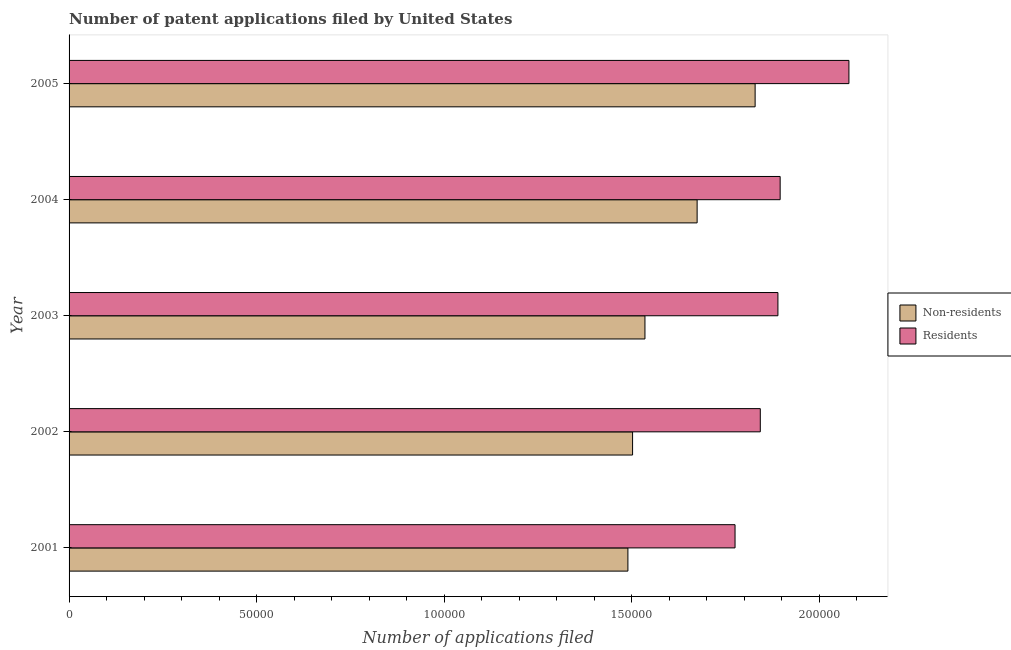Are the number of bars per tick equal to the number of legend labels?
Offer a terse response. Yes. How many bars are there on the 2nd tick from the top?
Make the answer very short. 2. How many bars are there on the 1st tick from the bottom?
Keep it short and to the point. 2. In how many cases, is the number of bars for a given year not equal to the number of legend labels?
Your response must be concise. 0. What is the number of patent applications by non residents in 2004?
Keep it short and to the point. 1.67e+05. Across all years, what is the maximum number of patent applications by residents?
Offer a very short reply. 2.08e+05. Across all years, what is the minimum number of patent applications by residents?
Keep it short and to the point. 1.78e+05. In which year was the number of patent applications by residents minimum?
Provide a short and direct response. 2001. What is the total number of patent applications by residents in the graph?
Make the answer very short. 9.48e+05. What is the difference between the number of patent applications by non residents in 2002 and that in 2005?
Your answer should be very brief. -3.27e+04. What is the difference between the number of patent applications by residents in 2004 and the number of patent applications by non residents in 2005?
Make the answer very short. 6670. What is the average number of patent applications by non residents per year?
Your answer should be compact. 1.61e+05. In the year 2001, what is the difference between the number of patent applications by residents and number of patent applications by non residents?
Give a very brief answer. 2.86e+04. What is the ratio of the number of patent applications by non residents in 2001 to that in 2005?
Keep it short and to the point. 0.81. Is the number of patent applications by non residents in 2001 less than that in 2002?
Offer a very short reply. Yes. What is the difference between the highest and the second highest number of patent applications by non residents?
Your answer should be very brief. 1.55e+04. What is the difference between the highest and the lowest number of patent applications by residents?
Keep it short and to the point. 3.04e+04. Is the sum of the number of patent applications by residents in 2001 and 2002 greater than the maximum number of patent applications by non residents across all years?
Ensure brevity in your answer.  Yes. What does the 2nd bar from the top in 2003 represents?
Make the answer very short. Non-residents. What does the 2nd bar from the bottom in 2005 represents?
Offer a terse response. Residents. How many bars are there?
Provide a short and direct response. 10. What is the difference between two consecutive major ticks on the X-axis?
Keep it short and to the point. 5.00e+04. Are the values on the major ticks of X-axis written in scientific E-notation?
Your answer should be compact. No. Where does the legend appear in the graph?
Provide a succinct answer. Center right. What is the title of the graph?
Provide a succinct answer. Number of patent applications filed by United States. Does "Borrowers" appear as one of the legend labels in the graph?
Provide a succinct answer. No. What is the label or title of the X-axis?
Make the answer very short. Number of applications filed. What is the Number of applications filed in Non-residents in 2001?
Keep it short and to the point. 1.49e+05. What is the Number of applications filed of Residents in 2001?
Give a very brief answer. 1.78e+05. What is the Number of applications filed of Non-residents in 2002?
Offer a terse response. 1.50e+05. What is the Number of applications filed in Residents in 2002?
Give a very brief answer. 1.84e+05. What is the Number of applications filed in Non-residents in 2003?
Offer a terse response. 1.54e+05. What is the Number of applications filed of Residents in 2003?
Your answer should be very brief. 1.89e+05. What is the Number of applications filed of Non-residents in 2004?
Offer a terse response. 1.67e+05. What is the Number of applications filed of Residents in 2004?
Ensure brevity in your answer.  1.90e+05. What is the Number of applications filed in Non-residents in 2005?
Your answer should be very brief. 1.83e+05. What is the Number of applications filed in Residents in 2005?
Make the answer very short. 2.08e+05. Across all years, what is the maximum Number of applications filed of Non-residents?
Offer a very short reply. 1.83e+05. Across all years, what is the maximum Number of applications filed in Residents?
Ensure brevity in your answer.  2.08e+05. Across all years, what is the minimum Number of applications filed in Non-residents?
Ensure brevity in your answer.  1.49e+05. Across all years, what is the minimum Number of applications filed of Residents?
Provide a succinct answer. 1.78e+05. What is the total Number of applications filed of Non-residents in the graph?
Provide a short and direct response. 8.03e+05. What is the total Number of applications filed in Residents in the graph?
Your response must be concise. 9.48e+05. What is the difference between the Number of applications filed of Non-residents in 2001 and that in 2002?
Provide a short and direct response. -1242. What is the difference between the Number of applications filed of Residents in 2001 and that in 2002?
Offer a terse response. -6732. What is the difference between the Number of applications filed of Non-residents in 2001 and that in 2003?
Keep it short and to the point. -4542. What is the difference between the Number of applications filed in Residents in 2001 and that in 2003?
Offer a very short reply. -1.14e+04. What is the difference between the Number of applications filed in Non-residents in 2001 and that in 2004?
Your answer should be very brief. -1.84e+04. What is the difference between the Number of applications filed in Residents in 2001 and that in 2004?
Your response must be concise. -1.20e+04. What is the difference between the Number of applications filed of Non-residents in 2001 and that in 2005?
Provide a short and direct response. -3.39e+04. What is the difference between the Number of applications filed of Residents in 2001 and that in 2005?
Give a very brief answer. -3.04e+04. What is the difference between the Number of applications filed in Non-residents in 2002 and that in 2003?
Offer a terse response. -3300. What is the difference between the Number of applications filed of Residents in 2002 and that in 2003?
Your response must be concise. -4696. What is the difference between the Number of applications filed of Non-residents in 2002 and that in 2004?
Offer a terse response. -1.72e+04. What is the difference between the Number of applications filed of Residents in 2002 and that in 2004?
Your answer should be very brief. -5291. What is the difference between the Number of applications filed of Non-residents in 2002 and that in 2005?
Offer a very short reply. -3.27e+04. What is the difference between the Number of applications filed of Residents in 2002 and that in 2005?
Your response must be concise. -2.36e+04. What is the difference between the Number of applications filed in Non-residents in 2003 and that in 2004?
Ensure brevity in your answer.  -1.39e+04. What is the difference between the Number of applications filed in Residents in 2003 and that in 2004?
Offer a terse response. -595. What is the difference between the Number of applications filed in Non-residents in 2003 and that in 2005?
Provide a short and direct response. -2.94e+04. What is the difference between the Number of applications filed of Residents in 2003 and that in 2005?
Offer a very short reply. -1.89e+04. What is the difference between the Number of applications filed in Non-residents in 2004 and that in 2005?
Give a very brief answer. -1.55e+04. What is the difference between the Number of applications filed in Residents in 2004 and that in 2005?
Provide a short and direct response. -1.83e+04. What is the difference between the Number of applications filed of Non-residents in 2001 and the Number of applications filed of Residents in 2002?
Keep it short and to the point. -3.53e+04. What is the difference between the Number of applications filed of Non-residents in 2001 and the Number of applications filed of Residents in 2003?
Offer a terse response. -4.00e+04. What is the difference between the Number of applications filed of Non-residents in 2001 and the Number of applications filed of Residents in 2004?
Offer a very short reply. -4.06e+04. What is the difference between the Number of applications filed of Non-residents in 2001 and the Number of applications filed of Residents in 2005?
Offer a very short reply. -5.89e+04. What is the difference between the Number of applications filed in Non-residents in 2002 and the Number of applications filed in Residents in 2003?
Keep it short and to the point. -3.87e+04. What is the difference between the Number of applications filed in Non-residents in 2002 and the Number of applications filed in Residents in 2004?
Your response must be concise. -3.93e+04. What is the difference between the Number of applications filed in Non-residents in 2002 and the Number of applications filed in Residents in 2005?
Give a very brief answer. -5.77e+04. What is the difference between the Number of applications filed of Non-residents in 2003 and the Number of applications filed of Residents in 2004?
Your response must be concise. -3.60e+04. What is the difference between the Number of applications filed of Non-residents in 2003 and the Number of applications filed of Residents in 2005?
Provide a short and direct response. -5.44e+04. What is the difference between the Number of applications filed in Non-residents in 2004 and the Number of applications filed in Residents in 2005?
Offer a very short reply. -4.05e+04. What is the average Number of applications filed of Non-residents per year?
Make the answer very short. 1.61e+05. What is the average Number of applications filed of Residents per year?
Your answer should be very brief. 1.90e+05. In the year 2001, what is the difference between the Number of applications filed of Non-residents and Number of applications filed of Residents?
Your answer should be very brief. -2.86e+04. In the year 2002, what is the difference between the Number of applications filed of Non-residents and Number of applications filed of Residents?
Give a very brief answer. -3.40e+04. In the year 2003, what is the difference between the Number of applications filed of Non-residents and Number of applications filed of Residents?
Your answer should be compact. -3.54e+04. In the year 2004, what is the difference between the Number of applications filed in Non-residents and Number of applications filed in Residents?
Offer a terse response. -2.21e+04. In the year 2005, what is the difference between the Number of applications filed of Non-residents and Number of applications filed of Residents?
Offer a very short reply. -2.50e+04. What is the ratio of the Number of applications filed in Residents in 2001 to that in 2002?
Provide a short and direct response. 0.96. What is the ratio of the Number of applications filed in Non-residents in 2001 to that in 2003?
Your answer should be very brief. 0.97. What is the ratio of the Number of applications filed of Residents in 2001 to that in 2003?
Give a very brief answer. 0.94. What is the ratio of the Number of applications filed of Non-residents in 2001 to that in 2004?
Provide a short and direct response. 0.89. What is the ratio of the Number of applications filed of Residents in 2001 to that in 2004?
Make the answer very short. 0.94. What is the ratio of the Number of applications filed of Non-residents in 2001 to that in 2005?
Make the answer very short. 0.81. What is the ratio of the Number of applications filed of Residents in 2001 to that in 2005?
Your answer should be compact. 0.85. What is the ratio of the Number of applications filed in Non-residents in 2002 to that in 2003?
Your answer should be compact. 0.98. What is the ratio of the Number of applications filed of Residents in 2002 to that in 2003?
Ensure brevity in your answer.  0.98. What is the ratio of the Number of applications filed in Non-residents in 2002 to that in 2004?
Offer a terse response. 0.9. What is the ratio of the Number of applications filed of Residents in 2002 to that in 2004?
Give a very brief answer. 0.97. What is the ratio of the Number of applications filed in Non-residents in 2002 to that in 2005?
Give a very brief answer. 0.82. What is the ratio of the Number of applications filed of Residents in 2002 to that in 2005?
Ensure brevity in your answer.  0.89. What is the ratio of the Number of applications filed in Non-residents in 2003 to that in 2004?
Your answer should be compact. 0.92. What is the ratio of the Number of applications filed of Non-residents in 2003 to that in 2005?
Ensure brevity in your answer.  0.84. What is the ratio of the Number of applications filed of Residents in 2003 to that in 2005?
Offer a very short reply. 0.91. What is the ratio of the Number of applications filed in Non-residents in 2004 to that in 2005?
Your response must be concise. 0.92. What is the ratio of the Number of applications filed in Residents in 2004 to that in 2005?
Offer a terse response. 0.91. What is the difference between the highest and the second highest Number of applications filed in Non-residents?
Ensure brevity in your answer.  1.55e+04. What is the difference between the highest and the second highest Number of applications filed in Residents?
Offer a very short reply. 1.83e+04. What is the difference between the highest and the lowest Number of applications filed of Non-residents?
Give a very brief answer. 3.39e+04. What is the difference between the highest and the lowest Number of applications filed in Residents?
Make the answer very short. 3.04e+04. 